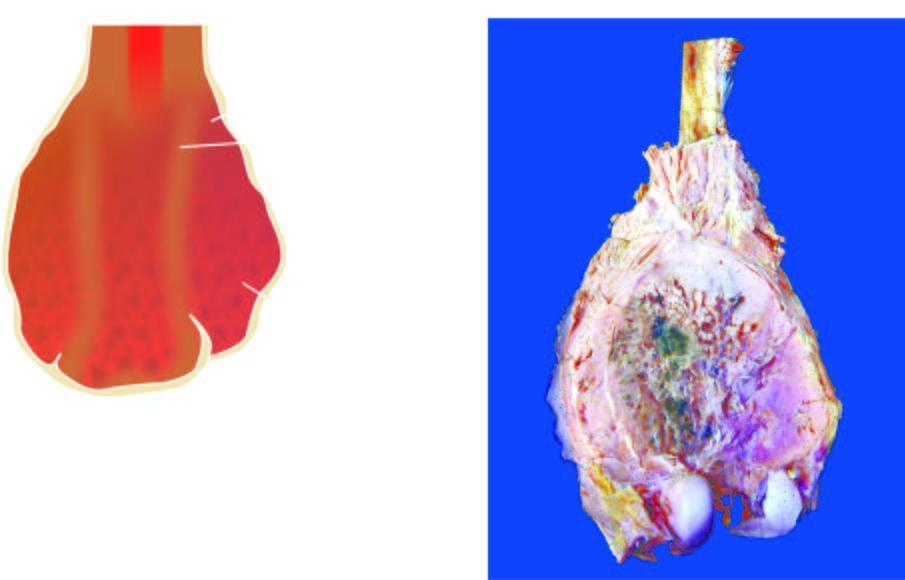what is the tumour?
Answer the question using a single word or phrase. Grey-white with areas of haemorrhage and necrosis 